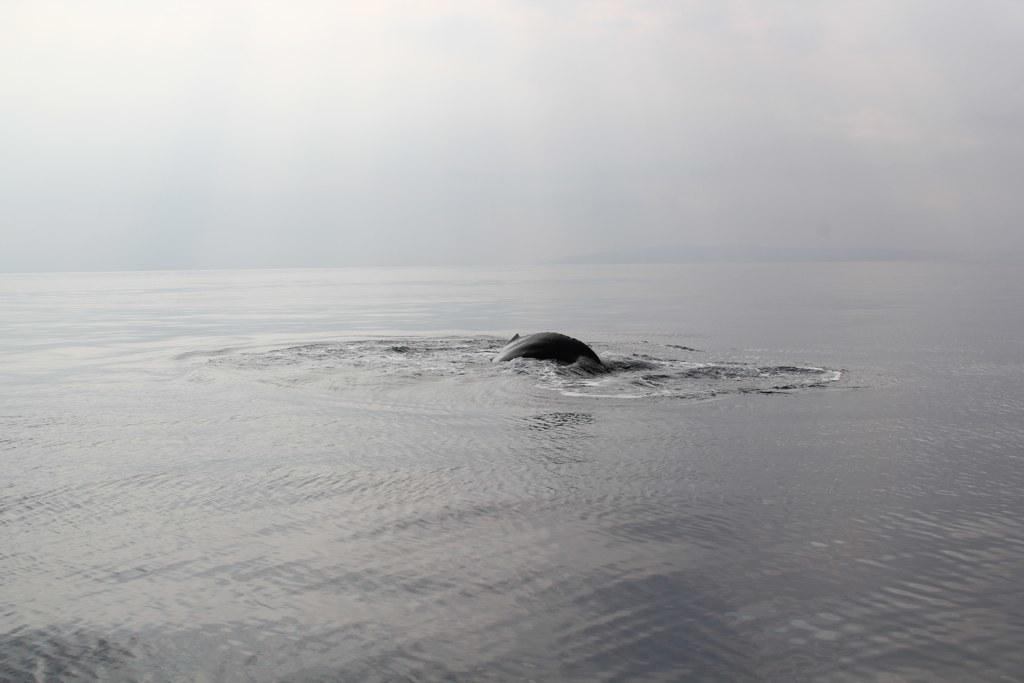What is the main subject in the center of the image? There is a shark in the center of the image. What type of water body is at the bottom of the image? There is a river at the bottom of the image. What part of the natural environment is visible at the top of the image? The sky is visible at the top of the image. What type of bears can be seen playing in the downtown area in the image? There are no bears or downtown area present in the image; it features a shark in a river with the sky visible above. 